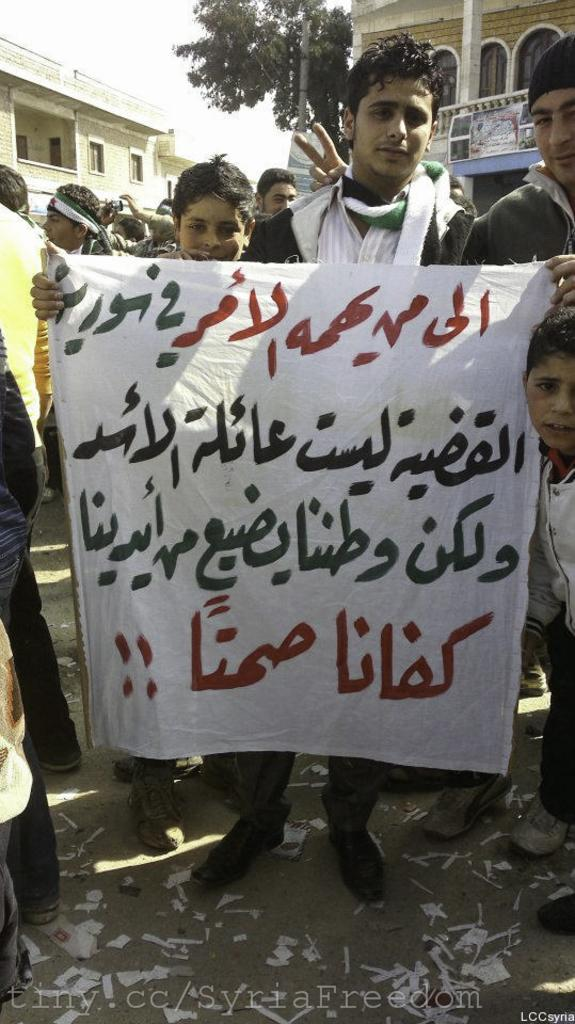What is the main subject of the image? There is a boy standing in the image. What is the boy holding in the image? The boy is holding a banner. Are there any other people in the image besides the boy? Yes, there are other people standing in the image. What type of structures can be seen in the image? There are buildings in the image. What natural element is present in the image? There is a tree in the image. What is visible in the background of the image? The sky is visible in the image. Where is the cave located in the image? There is no cave present in the image. What type of game are the people playing in the image? There is no game being played in the image. 